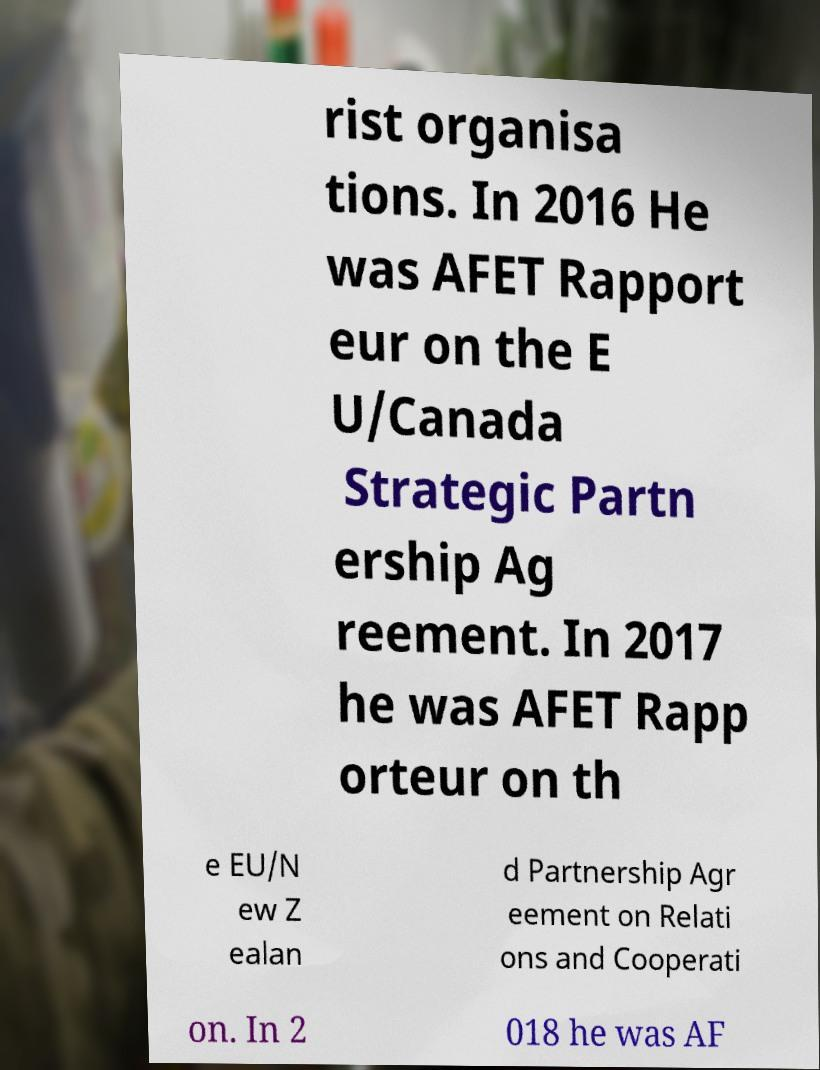For documentation purposes, I need the text within this image transcribed. Could you provide that? rist organisa tions. In 2016 He was AFET Rapport eur on the E U/Canada Strategic Partn ership Ag reement. In 2017 he was AFET Rapp orteur on th e EU/N ew Z ealan d Partnership Agr eement on Relati ons and Cooperati on. In 2 018 he was AF 